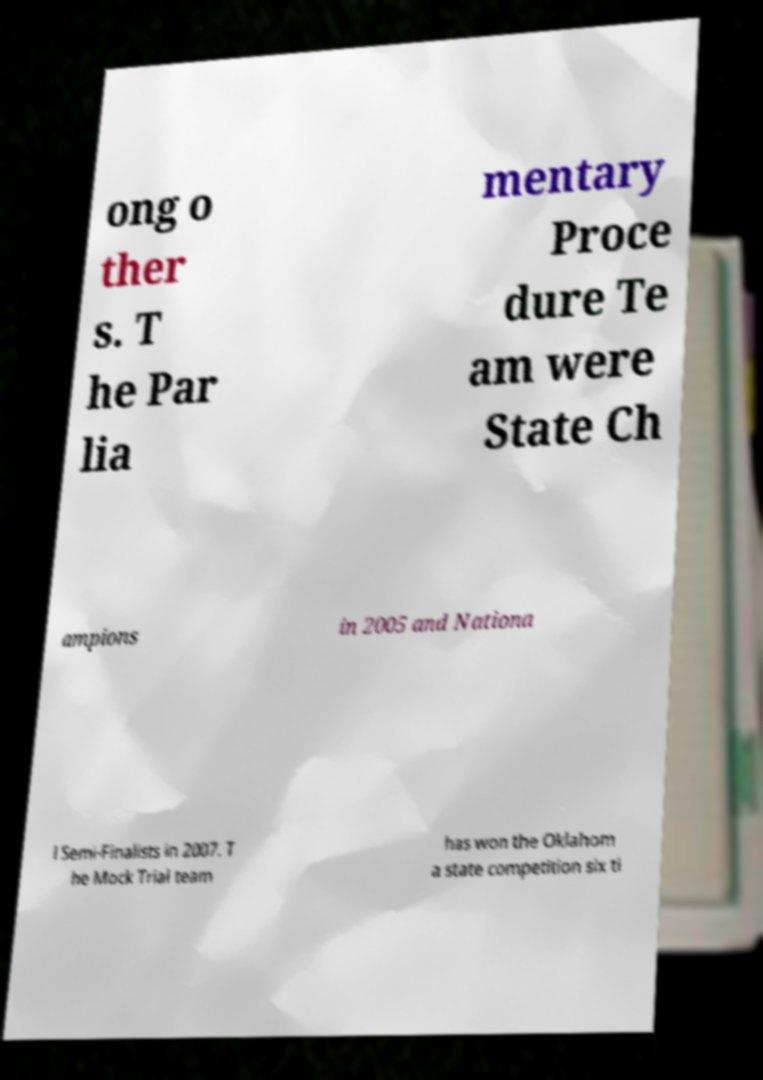Could you extract and type out the text from this image? ong o ther s. T he Par lia mentary Proce dure Te am were State Ch ampions in 2005 and Nationa l Semi-Finalists in 2007. T he Mock Trial team has won the Oklahom a state competition six ti 